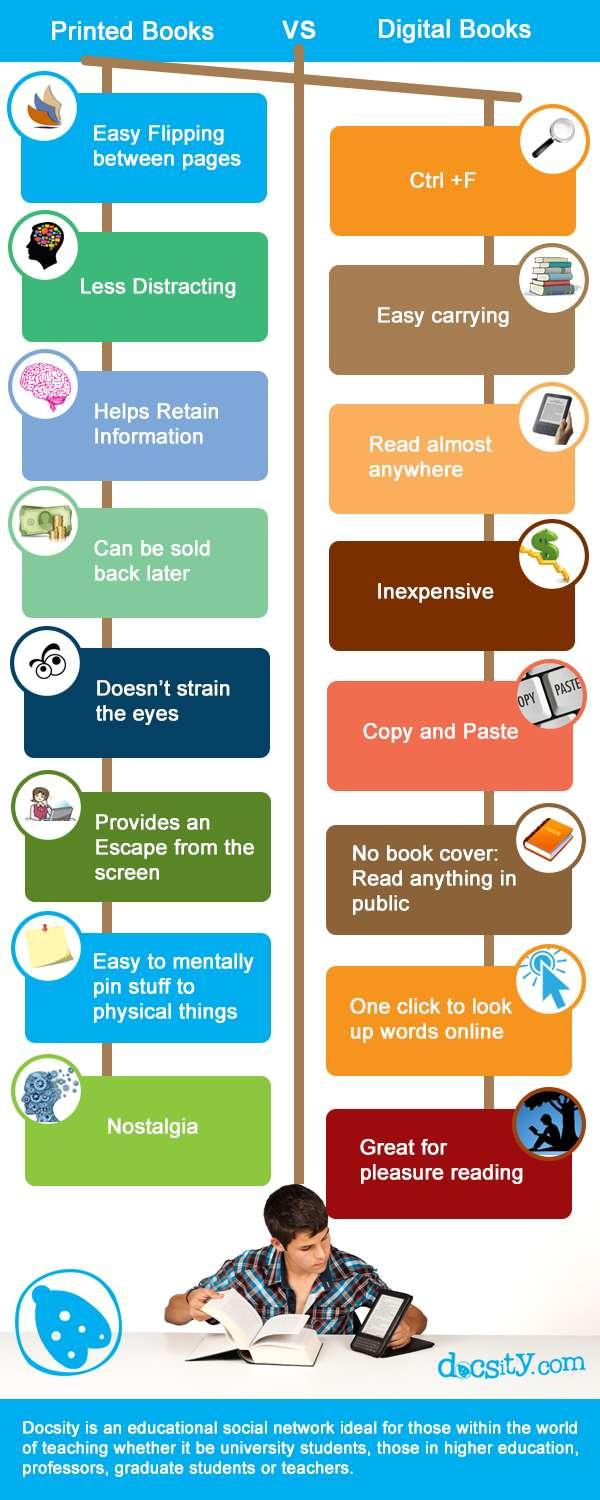List a handful of essential elements in this visual. Printed books are less distracting than digital books. Printed books are known to be effective in helping to retain information. Digital books are the easiest to carry because they do not take up physical space and can be accessed anywhere with a device. Digital books provide numerous advantages, and one of them is the ability to read almost anywhere. Printed books offer the benefit of not straining the eyes, which is the fifth advantage mentioned. 